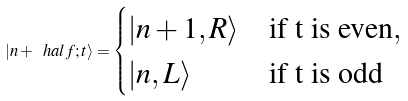<formula> <loc_0><loc_0><loc_500><loc_500>| n + \ h a l f ; t \rangle = \begin{cases} | n + 1 , R \rangle & \text {if {t} is even} , \\ | n , L \rangle & \text {if {t} is odd} \end{cases}</formula> 